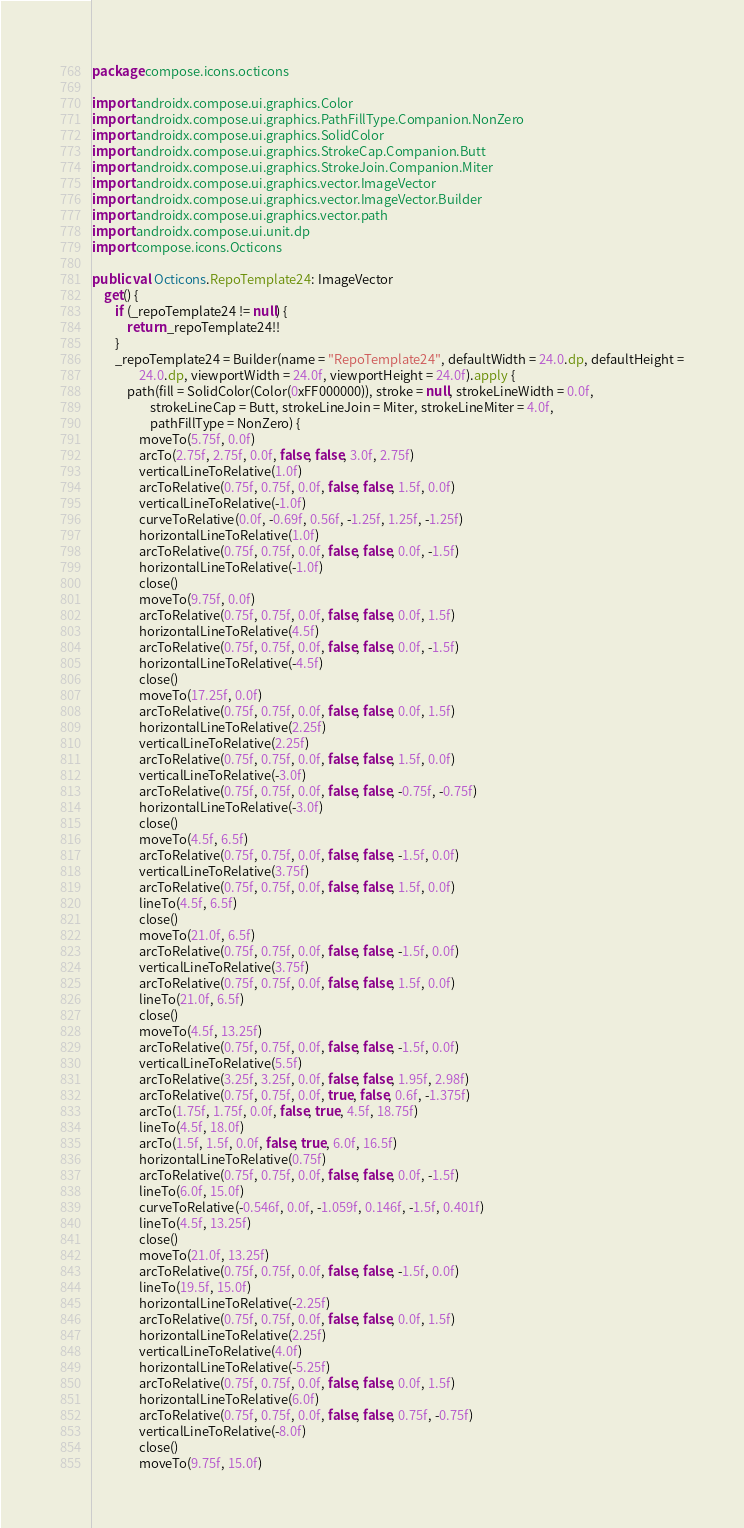<code> <loc_0><loc_0><loc_500><loc_500><_Kotlin_>package compose.icons.octicons

import androidx.compose.ui.graphics.Color
import androidx.compose.ui.graphics.PathFillType.Companion.NonZero
import androidx.compose.ui.graphics.SolidColor
import androidx.compose.ui.graphics.StrokeCap.Companion.Butt
import androidx.compose.ui.graphics.StrokeJoin.Companion.Miter
import androidx.compose.ui.graphics.vector.ImageVector
import androidx.compose.ui.graphics.vector.ImageVector.Builder
import androidx.compose.ui.graphics.vector.path
import androidx.compose.ui.unit.dp
import compose.icons.Octicons

public val Octicons.RepoTemplate24: ImageVector
    get() {
        if (_repoTemplate24 != null) {
            return _repoTemplate24!!
        }
        _repoTemplate24 = Builder(name = "RepoTemplate24", defaultWidth = 24.0.dp, defaultHeight =
                24.0.dp, viewportWidth = 24.0f, viewportHeight = 24.0f).apply {
            path(fill = SolidColor(Color(0xFF000000)), stroke = null, strokeLineWidth = 0.0f,
                    strokeLineCap = Butt, strokeLineJoin = Miter, strokeLineMiter = 4.0f,
                    pathFillType = NonZero) {
                moveTo(5.75f, 0.0f)
                arcTo(2.75f, 2.75f, 0.0f, false, false, 3.0f, 2.75f)
                verticalLineToRelative(1.0f)
                arcToRelative(0.75f, 0.75f, 0.0f, false, false, 1.5f, 0.0f)
                verticalLineToRelative(-1.0f)
                curveToRelative(0.0f, -0.69f, 0.56f, -1.25f, 1.25f, -1.25f)
                horizontalLineToRelative(1.0f)
                arcToRelative(0.75f, 0.75f, 0.0f, false, false, 0.0f, -1.5f)
                horizontalLineToRelative(-1.0f)
                close()
                moveTo(9.75f, 0.0f)
                arcToRelative(0.75f, 0.75f, 0.0f, false, false, 0.0f, 1.5f)
                horizontalLineToRelative(4.5f)
                arcToRelative(0.75f, 0.75f, 0.0f, false, false, 0.0f, -1.5f)
                horizontalLineToRelative(-4.5f)
                close()
                moveTo(17.25f, 0.0f)
                arcToRelative(0.75f, 0.75f, 0.0f, false, false, 0.0f, 1.5f)
                horizontalLineToRelative(2.25f)
                verticalLineToRelative(2.25f)
                arcToRelative(0.75f, 0.75f, 0.0f, false, false, 1.5f, 0.0f)
                verticalLineToRelative(-3.0f)
                arcToRelative(0.75f, 0.75f, 0.0f, false, false, -0.75f, -0.75f)
                horizontalLineToRelative(-3.0f)
                close()
                moveTo(4.5f, 6.5f)
                arcToRelative(0.75f, 0.75f, 0.0f, false, false, -1.5f, 0.0f)
                verticalLineToRelative(3.75f)
                arcToRelative(0.75f, 0.75f, 0.0f, false, false, 1.5f, 0.0f)
                lineTo(4.5f, 6.5f)
                close()
                moveTo(21.0f, 6.5f)
                arcToRelative(0.75f, 0.75f, 0.0f, false, false, -1.5f, 0.0f)
                verticalLineToRelative(3.75f)
                arcToRelative(0.75f, 0.75f, 0.0f, false, false, 1.5f, 0.0f)
                lineTo(21.0f, 6.5f)
                close()
                moveTo(4.5f, 13.25f)
                arcToRelative(0.75f, 0.75f, 0.0f, false, false, -1.5f, 0.0f)
                verticalLineToRelative(5.5f)
                arcToRelative(3.25f, 3.25f, 0.0f, false, false, 1.95f, 2.98f)
                arcToRelative(0.75f, 0.75f, 0.0f, true, false, 0.6f, -1.375f)
                arcTo(1.75f, 1.75f, 0.0f, false, true, 4.5f, 18.75f)
                lineTo(4.5f, 18.0f)
                arcTo(1.5f, 1.5f, 0.0f, false, true, 6.0f, 16.5f)
                horizontalLineToRelative(0.75f)
                arcToRelative(0.75f, 0.75f, 0.0f, false, false, 0.0f, -1.5f)
                lineTo(6.0f, 15.0f)
                curveToRelative(-0.546f, 0.0f, -1.059f, 0.146f, -1.5f, 0.401f)
                lineTo(4.5f, 13.25f)
                close()
                moveTo(21.0f, 13.25f)
                arcToRelative(0.75f, 0.75f, 0.0f, false, false, -1.5f, 0.0f)
                lineTo(19.5f, 15.0f)
                horizontalLineToRelative(-2.25f)
                arcToRelative(0.75f, 0.75f, 0.0f, false, false, 0.0f, 1.5f)
                horizontalLineToRelative(2.25f)
                verticalLineToRelative(4.0f)
                horizontalLineToRelative(-5.25f)
                arcToRelative(0.75f, 0.75f, 0.0f, false, false, 0.0f, 1.5f)
                horizontalLineToRelative(6.0f)
                arcToRelative(0.75f, 0.75f, 0.0f, false, false, 0.75f, -0.75f)
                verticalLineToRelative(-8.0f)
                close()
                moveTo(9.75f, 15.0f)</code> 